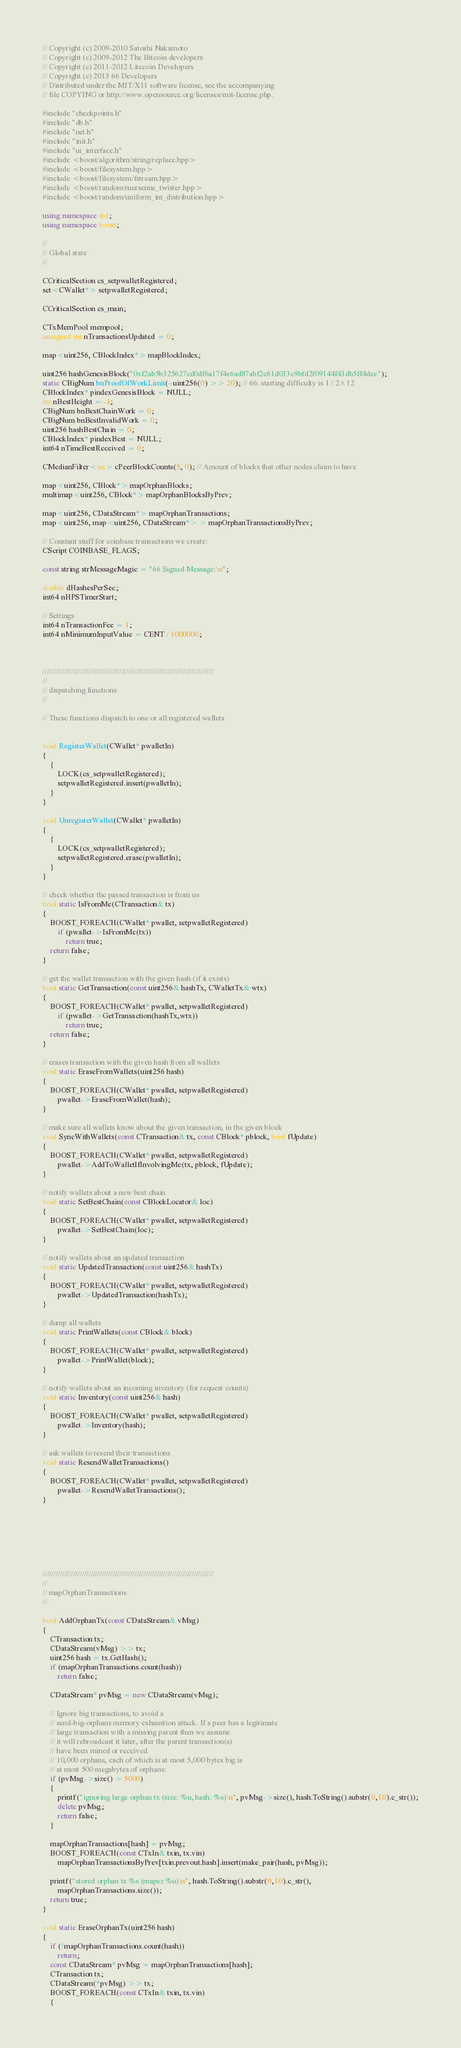<code> <loc_0><loc_0><loc_500><loc_500><_C++_>// Copyright (c) 2009-2010 Satoshi Nakamoto
// Copyright (c) 2009-2012 The Bitcoin developers
// Copyright (c) 2011-2012 Litecoin Developers
// Copyright (c) 2013 66 Developers
// Distributed under the MIT/X11 software license, see the accompanying
// file COPYING or http://www.opensource.org/licenses/mit-license.php.

#include "checkpoints.h"
#include "db.h"
#include "net.h"
#include "init.h"
#include "ui_interface.h"
#include <boost/algorithm/string/replace.hpp>
#include <boost/filesystem.hpp>
#include <boost/filesystem/fstream.hpp>
#include <boost/random/mersenne_twister.hpp>
#include <boost/random/uniform_int_distribution.hpp>

using namespace std;
using namespace boost;

//
// Global state
//

CCriticalSection cs_setpwalletRegistered;
set<CWallet*> setpwalletRegistered;

CCriticalSection cs_main;

CTxMemPool mempool;
unsigned int nTransactionsUpdated = 0;

map<uint256, CBlockIndex*> mapBlockIndex;

uint256 hashGenesisBlock("0xf2ab5b325627cd0df6a17f4e6ad87abf2c61d033c9bfd2f09144f43db5ff4dee");
static CBigNum bnProofOfWorkLimit(~uint256(0) >> 20); // 66: starting difficulty is 1 / 2^12
CBlockIndex* pindexGenesisBlock = NULL;
int nBestHeight = -1;
CBigNum bnBestChainWork = 0;
CBigNum bnBestInvalidWork = 0;
uint256 hashBestChain = 0;
CBlockIndex* pindexBest = NULL;
int64 nTimeBestReceived = 0;

CMedianFilter<int> cPeerBlockCounts(5, 0); // Amount of blocks that other nodes claim to have

map<uint256, CBlock*> mapOrphanBlocks;
multimap<uint256, CBlock*> mapOrphanBlocksByPrev;

map<uint256, CDataStream*> mapOrphanTransactions;
map<uint256, map<uint256, CDataStream*> > mapOrphanTransactionsByPrev;

// Constant stuff for coinbase transactions we create:
CScript COINBASE_FLAGS;

const string strMessageMagic = "66 Signed Message:\n";

double dHashesPerSec;
int64 nHPSTimerStart;

// Settings
int64 nTransactionFee = 1;
int64 nMinimumInputValue = CENT / 1000000;



//////////////////////////////////////////////////////////////////////////////
//
// dispatching functions
//

// These functions dispatch to one or all registered wallets


void RegisterWallet(CWallet* pwalletIn)
{
    {
        LOCK(cs_setpwalletRegistered);
        setpwalletRegistered.insert(pwalletIn);
    }
}

void UnregisterWallet(CWallet* pwalletIn)
{
    {
        LOCK(cs_setpwalletRegistered);
        setpwalletRegistered.erase(pwalletIn);
    }
}

// check whether the passed transaction is from us
bool static IsFromMe(CTransaction& tx)
{
    BOOST_FOREACH(CWallet* pwallet, setpwalletRegistered)
        if (pwallet->IsFromMe(tx))
            return true;
    return false;
}

// get the wallet transaction with the given hash (if it exists)
bool static GetTransaction(const uint256& hashTx, CWalletTx& wtx)
{
    BOOST_FOREACH(CWallet* pwallet, setpwalletRegistered)
        if (pwallet->GetTransaction(hashTx,wtx))
            return true;
    return false;
}

// erases transaction with the given hash from all wallets
void static EraseFromWallets(uint256 hash)
{
    BOOST_FOREACH(CWallet* pwallet, setpwalletRegistered)
        pwallet->EraseFromWallet(hash);
}

// make sure all wallets know about the given transaction, in the given block
void SyncWithWallets(const CTransaction& tx, const CBlock* pblock, bool fUpdate)
{
    BOOST_FOREACH(CWallet* pwallet, setpwalletRegistered)
        pwallet->AddToWalletIfInvolvingMe(tx, pblock, fUpdate);
}

// notify wallets about a new best chain
void static SetBestChain(const CBlockLocator& loc)
{
    BOOST_FOREACH(CWallet* pwallet, setpwalletRegistered)
        pwallet->SetBestChain(loc);
}

// notify wallets about an updated transaction
void static UpdatedTransaction(const uint256& hashTx)
{
    BOOST_FOREACH(CWallet* pwallet, setpwalletRegistered)
        pwallet->UpdatedTransaction(hashTx);
}

// dump all wallets
void static PrintWallets(const CBlock& block)
{
    BOOST_FOREACH(CWallet* pwallet, setpwalletRegistered)
        pwallet->PrintWallet(block);
}

// notify wallets about an incoming inventory (for request counts)
void static Inventory(const uint256& hash)
{
    BOOST_FOREACH(CWallet* pwallet, setpwalletRegistered)
        pwallet->Inventory(hash);
}

// ask wallets to resend their transactions
void static ResendWalletTransactions()
{
    BOOST_FOREACH(CWallet* pwallet, setpwalletRegistered)
        pwallet->ResendWalletTransactions();
}







//////////////////////////////////////////////////////////////////////////////
//
// mapOrphanTransactions
//

bool AddOrphanTx(const CDataStream& vMsg)
{
    CTransaction tx;
    CDataStream(vMsg) >> tx;
    uint256 hash = tx.GetHash();
    if (mapOrphanTransactions.count(hash))
        return false;

    CDataStream* pvMsg = new CDataStream(vMsg);

    // Ignore big transactions, to avoid a
    // send-big-orphans memory exhaustion attack. If a peer has a legitimate
    // large transaction with a missing parent then we assume
    // it will rebroadcast it later, after the parent transaction(s)
    // have been mined or received.
    // 10,000 orphans, each of which is at most 5,000 bytes big is
    // at most 500 megabytes of orphans:
    if (pvMsg->size() > 5000)
    {
        printf("ignoring large orphan tx (size: %u, hash: %s)\n", pvMsg->size(), hash.ToString().substr(0,10).c_str());
        delete pvMsg;
        return false;
    }

    mapOrphanTransactions[hash] = pvMsg;
    BOOST_FOREACH(const CTxIn& txin, tx.vin)
        mapOrphanTransactionsByPrev[txin.prevout.hash].insert(make_pair(hash, pvMsg));

    printf("stored orphan tx %s (mapsz %u)\n", hash.ToString().substr(0,10).c_str(),
        mapOrphanTransactions.size());
    return true;
}

void static EraseOrphanTx(uint256 hash)
{
    if (!mapOrphanTransactions.count(hash))
        return;
    const CDataStream* pvMsg = mapOrphanTransactions[hash];
    CTransaction tx;
    CDataStream(*pvMsg) >> tx;
    BOOST_FOREACH(const CTxIn& txin, tx.vin)
    {</code> 